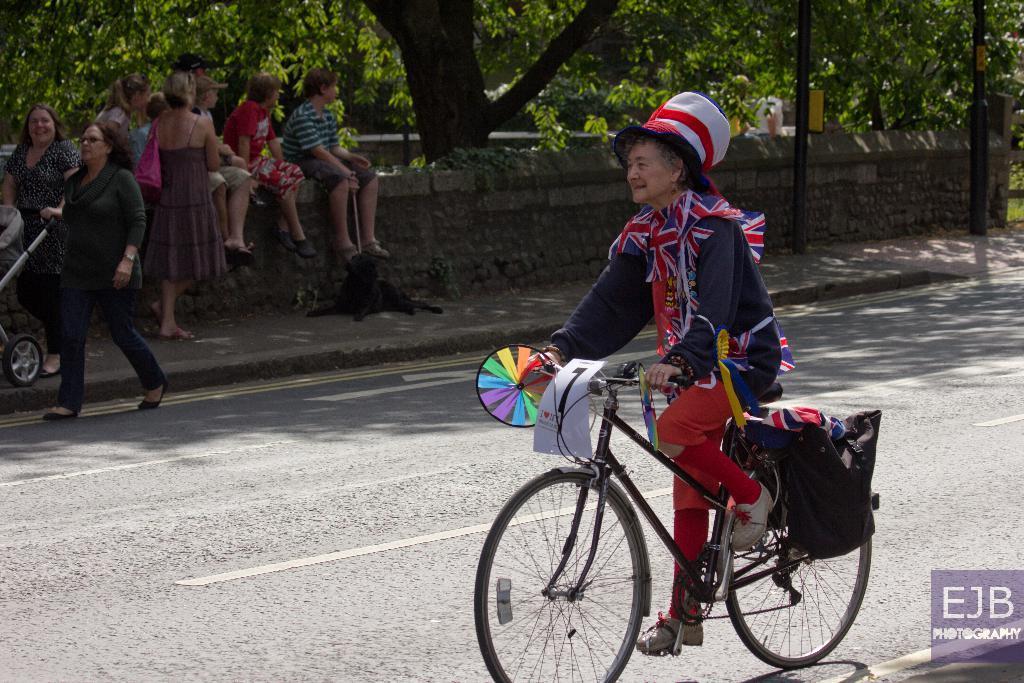Please provide a concise description of this image. There is a old woman riding a bicycle on the road in this picture and there are some people sitting on the wall. There is a dog. Some people are walking. In the background, there are some trees and poles here. 